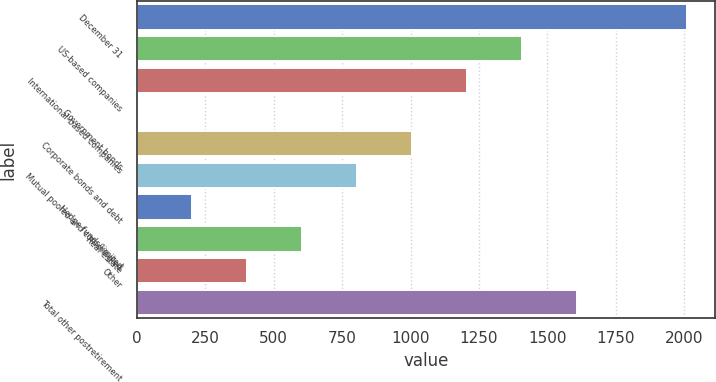Convert chart. <chart><loc_0><loc_0><loc_500><loc_500><bar_chart><fcel>December 31<fcel>US-based companies<fcel>International-based companies<fcel>Government bonds<fcel>Corporate bonds and debt<fcel>Mutual pooled and commingled<fcel>Hedge funds/limited<fcel>Real estate<fcel>Other<fcel>Total other postretirement<nl><fcel>2010<fcel>1407.3<fcel>1206.4<fcel>1<fcel>1005.5<fcel>804.6<fcel>201.9<fcel>603.7<fcel>402.8<fcel>1608.2<nl></chart> 